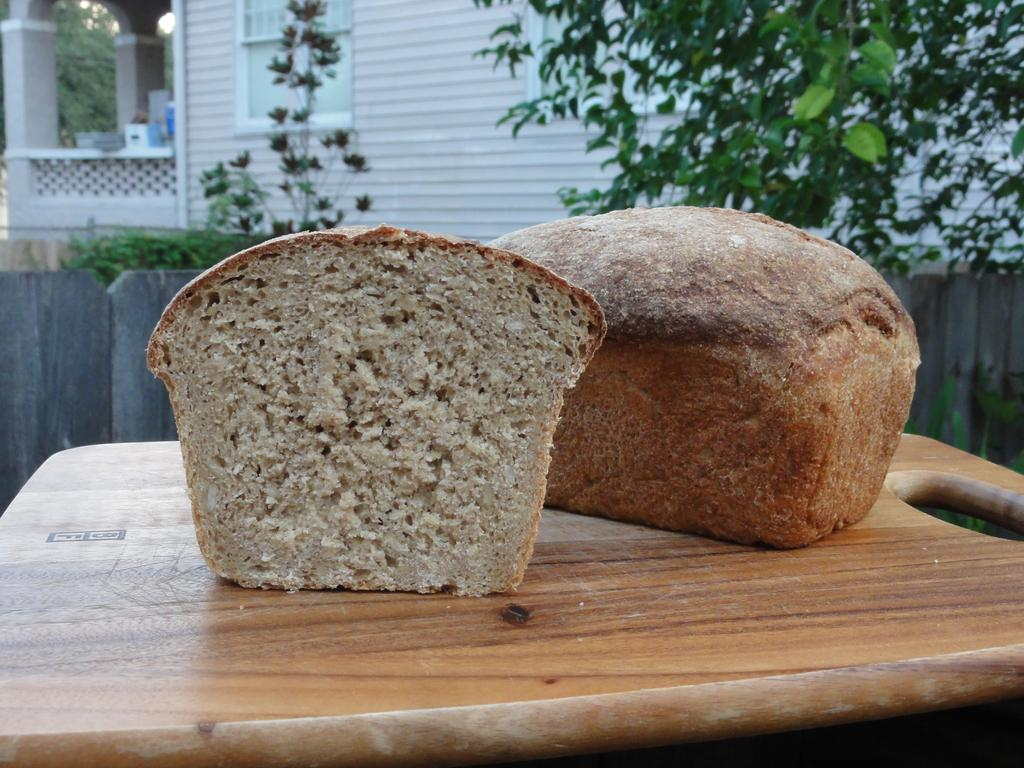What type of food can be seen in the image? There are loaves of bread in the image. Where are the loaves of bread placed? The loaves of bread are placed on a chopping board. What can be seen in the background of the image? There is a porch, windows, a building, trees, bushes, and the sky visible in the background of the image. What type of nerve is visible in the image? There is no nerve visible in the image; it features loaves of bread on a chopping board and a background with various elements. 